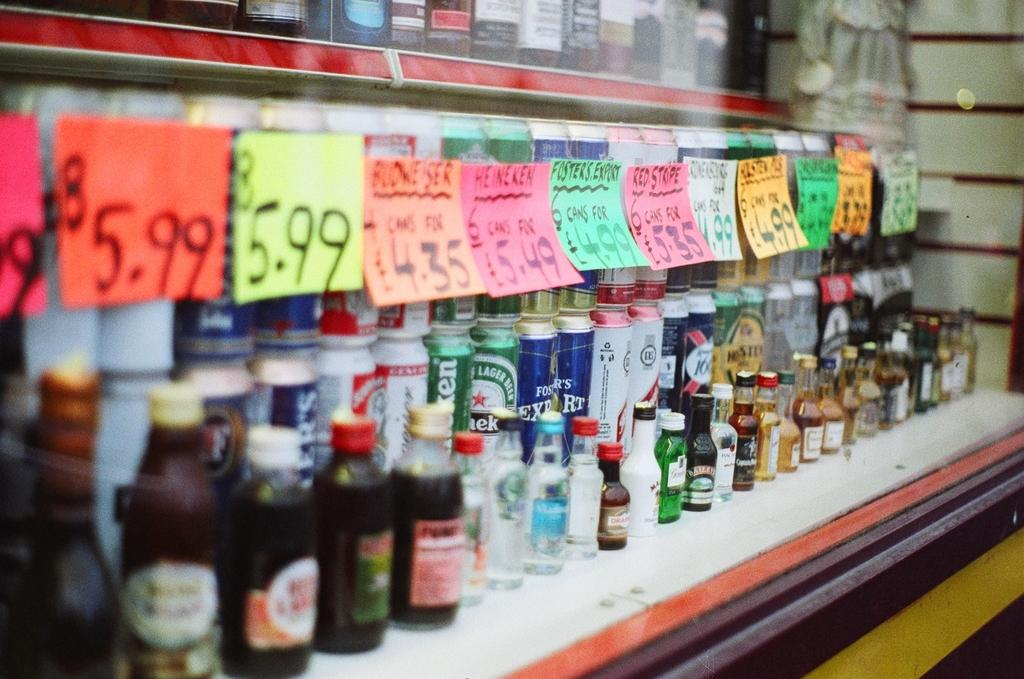<image>
Share a concise interpretation of the image provided. Many cans and bottles on a shelf including one that costs 5.99. 